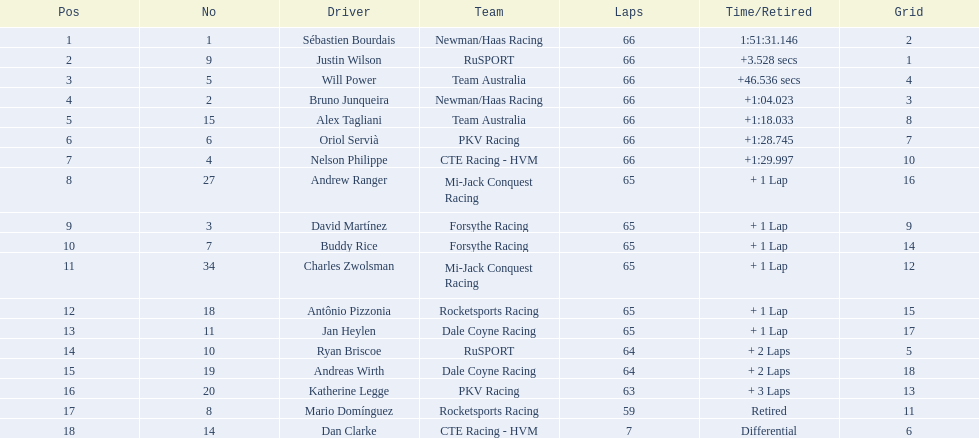What was the highest amount of points scored in the 2006 gran premio? 34. Who scored 34 points? Sébastien Bourdais. 